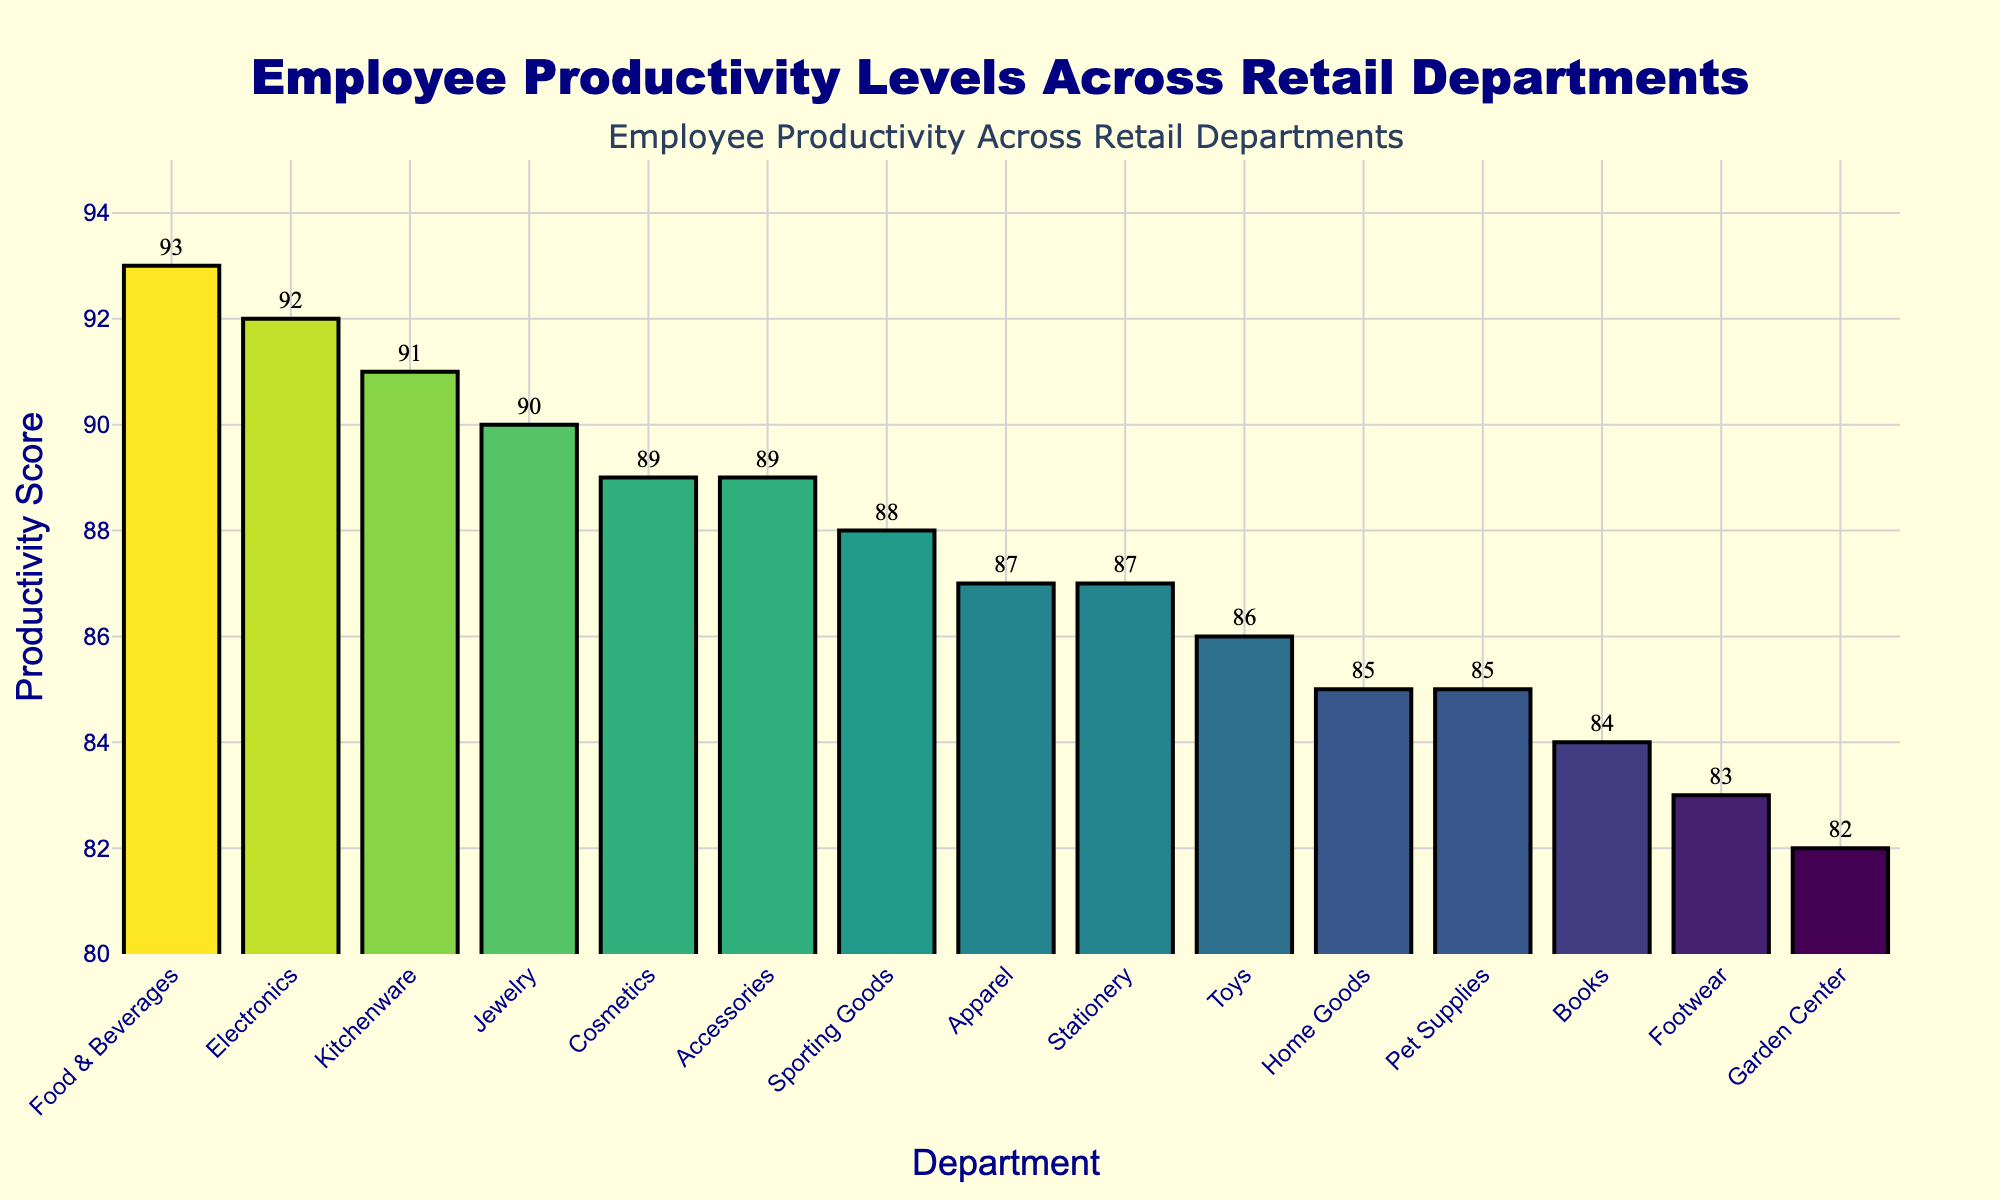Which department has the highest productivity score? Look for the department with the tallest bar. "Food & Beverages" has the highest bar extending to a score of 93.
Answer: Food & Beverages What is the productivity score range among the departments? The range is calculated by subtracting the lowest score from the highest score. "Garden Center" has the lowest score of 82, and "Food & Beverages" has the highest score of 93. So, the range is 93 - 82.
Answer: 11 Which department has the lowest productivity score? Identify the department with the shortest bar. "Garden Center" has the shortest bar of 82.
Answer: Garden Center How many departments have a productivity score of 89 or higher? Count the number of bars that extend to a productivity score of 89 or higher. Departments falling into this category are "Electronics," "Cosmetics," "Jewelry," "Kitchenware," "Accessories," and "Food & Beverages." There are 6 such departments.
Answer: 6 departments What is the average productivity score of "Apparel" and "Footwear"? Add the productivity scores of "Apparel" (87) and "Footwear" (83) and divide by 2. (87 + 83) / 2 = 85
Answer: 85 How does the productivity score of "Books" compare to "Pet Supplies"? Identify the productivity scores of both departments. "Books" has a score of 84 and "Pet Supplies" has a score of 85. "Books" is lower.
Answer: Books has a lower score than Pet Supplies Which department has a higher productivity score: "Sporting Goods" or "Home Goods"? Compare the productivity scores of "Sporting Goods" (88) and "Home Goods" (85). "Sporting Goods" is higher.
Answer: Sporting Goods What is the combined productivity score of "Apparel," "Home Goods," and "Books"? Add the productivity scores of "Apparel" (87), "Home Goods" (85), and "Books" (84). 87 + 85 + 84 = 256
Answer: 256 Which department is just below "Jewelry" in productivity score? Review the sorted department bars. "Accessories" (89) is just below "Jewelry" (90).
Answer: Accessories What is the median productivity score among all departments? Sort departments by productivity scores and find the middle value. The sorted scores are 82, 83, 84, 85, 85, 86, 87, 87, 88, 89, 89, 90, 91, 92, 93. Since there are 15 values, the median is the 8th value, which is 87.
Answer: 87 